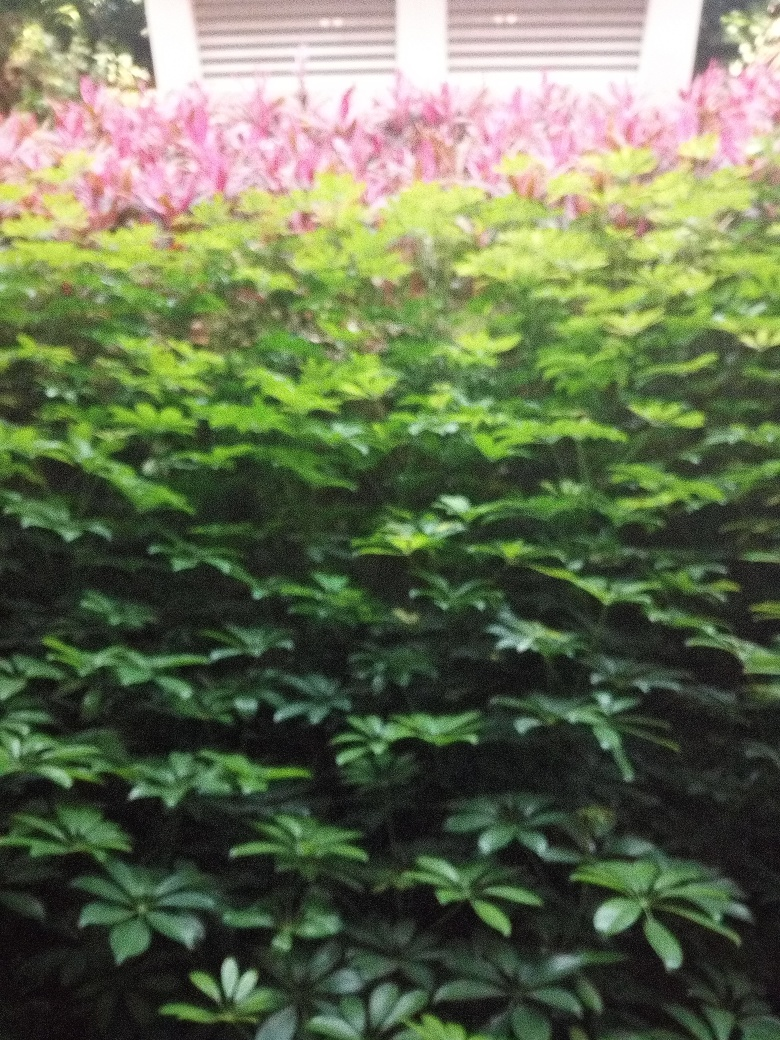Can you tell me more about the different types of plants in the image? The image features a variety of plants, including some with vibrant pink leaves likely to be a species of Alternanthera, known for their colorful foliage. The green shrubs could be a type of boxwood, which are common in ornamental gardening for their dense, evergreen leaves. 